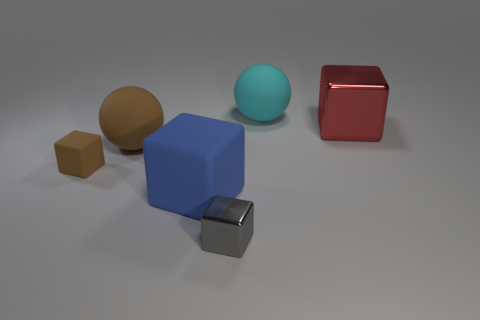Add 1 big red metal cubes. How many objects exist? 7 Subtract all gray cubes. How many cubes are left? 3 Subtract 1 spheres. How many spheres are left? 1 Add 2 small yellow matte cubes. How many small yellow matte cubes exist? 2 Subtract 1 blue cubes. How many objects are left? 5 Subtract all blocks. How many objects are left? 2 Subtract all red cubes. Subtract all purple cylinders. How many cubes are left? 3 Subtract all purple balls. How many cyan cubes are left? 0 Subtract all tiny red metallic cubes. Subtract all blue matte cubes. How many objects are left? 5 Add 2 gray metal blocks. How many gray metal blocks are left? 3 